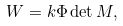Convert formula to latex. <formula><loc_0><loc_0><loc_500><loc_500>W = k \Phi \det M ,</formula> 